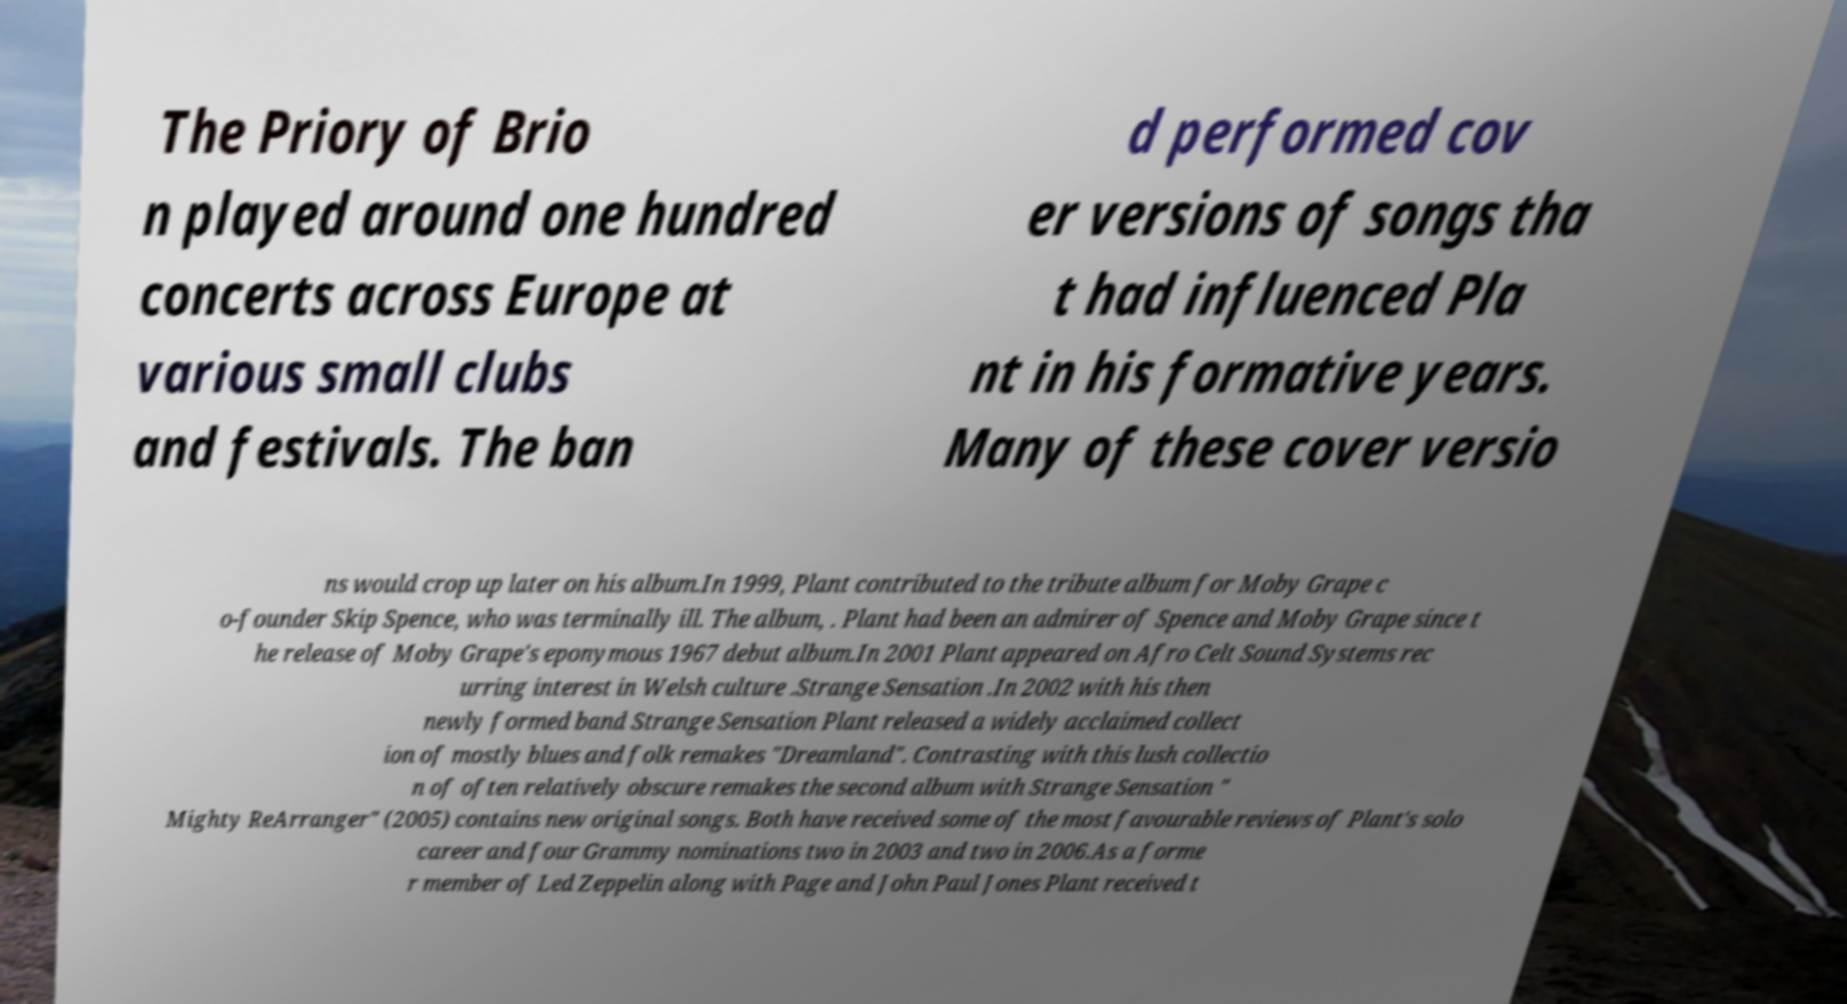There's text embedded in this image that I need extracted. Can you transcribe it verbatim? The Priory of Brio n played around one hundred concerts across Europe at various small clubs and festivals. The ban d performed cov er versions of songs tha t had influenced Pla nt in his formative years. Many of these cover versio ns would crop up later on his album.In 1999, Plant contributed to the tribute album for Moby Grape c o-founder Skip Spence, who was terminally ill. The album, . Plant had been an admirer of Spence and Moby Grape since t he release of Moby Grape's eponymous 1967 debut album.In 2001 Plant appeared on Afro Celt Sound Systems rec urring interest in Welsh culture .Strange Sensation .In 2002 with his then newly formed band Strange Sensation Plant released a widely acclaimed collect ion of mostly blues and folk remakes "Dreamland". Contrasting with this lush collectio n of often relatively obscure remakes the second album with Strange Sensation " Mighty ReArranger" (2005) contains new original songs. Both have received some of the most favourable reviews of Plant's solo career and four Grammy nominations two in 2003 and two in 2006.As a forme r member of Led Zeppelin along with Page and John Paul Jones Plant received t 